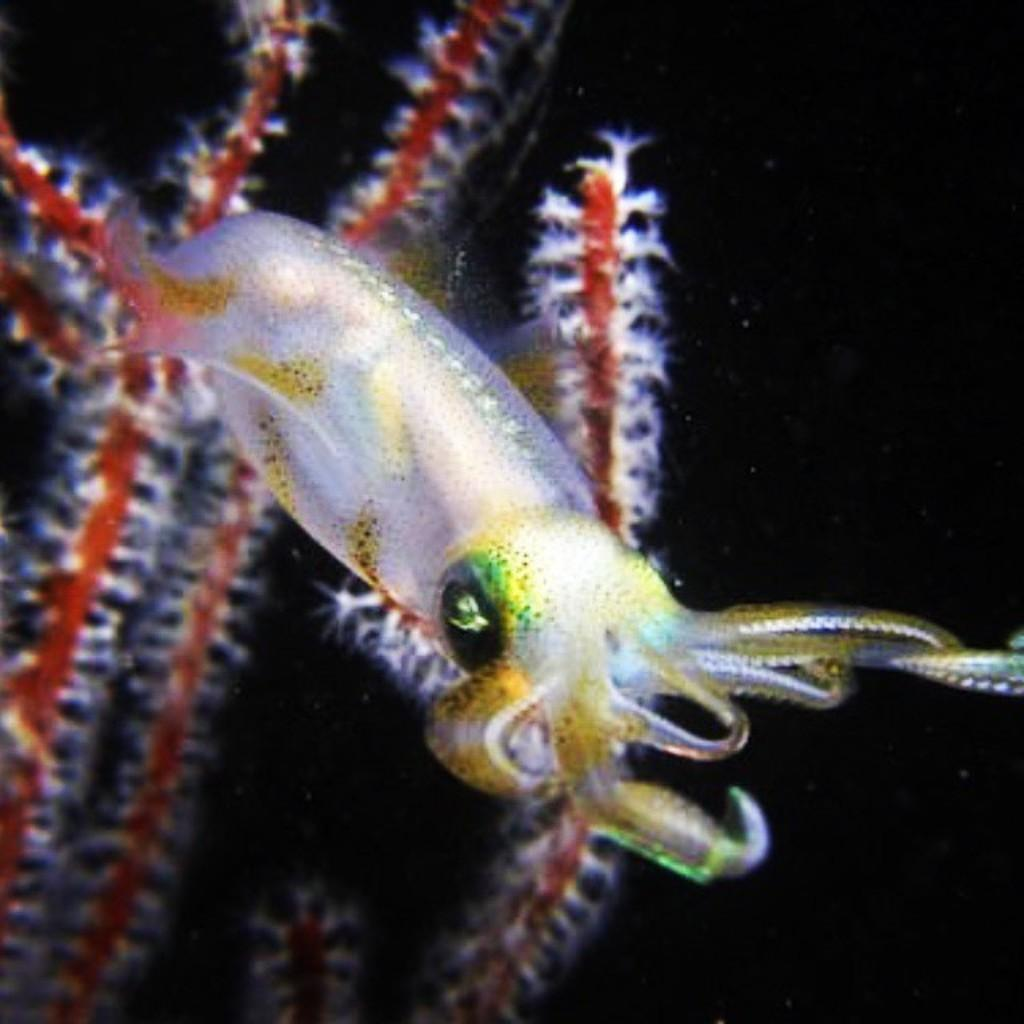What type of sea creature is in the image? There is a white-colored squid in the image. What color are the other objects in the image? There are red-colored things in the image. What color is the background of the image? The background of the image is black. How many rabbits can be seen growing a sock in the image? There are no rabbits or socks present in the image. 